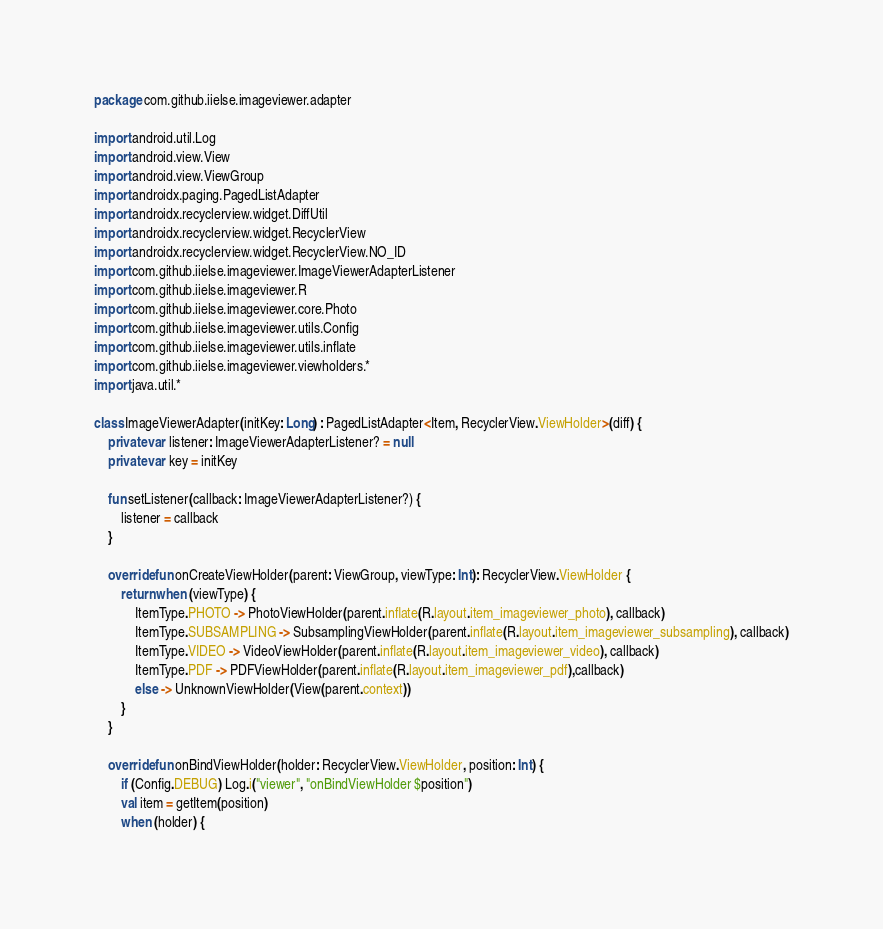<code> <loc_0><loc_0><loc_500><loc_500><_Kotlin_>package com.github.iielse.imageviewer.adapter

import android.util.Log
import android.view.View
import android.view.ViewGroup
import androidx.paging.PagedListAdapter
import androidx.recyclerview.widget.DiffUtil
import androidx.recyclerview.widget.RecyclerView
import androidx.recyclerview.widget.RecyclerView.NO_ID
import com.github.iielse.imageviewer.ImageViewerAdapterListener
import com.github.iielse.imageviewer.R
import com.github.iielse.imageviewer.core.Photo
import com.github.iielse.imageviewer.utils.Config
import com.github.iielse.imageviewer.utils.inflate
import com.github.iielse.imageviewer.viewholders.*
import java.util.*

class ImageViewerAdapter(initKey: Long) : PagedListAdapter<Item, RecyclerView.ViewHolder>(diff) {
    private var listener: ImageViewerAdapterListener? = null
    private var key = initKey

    fun setListener(callback: ImageViewerAdapterListener?) {
        listener = callback
    }

    override fun onCreateViewHolder(parent: ViewGroup, viewType: Int): RecyclerView.ViewHolder {
        return when (viewType) {
            ItemType.PHOTO -> PhotoViewHolder(parent.inflate(R.layout.item_imageviewer_photo), callback)
            ItemType.SUBSAMPLING -> SubsamplingViewHolder(parent.inflate(R.layout.item_imageviewer_subsampling), callback)
            ItemType.VIDEO -> VideoViewHolder(parent.inflate(R.layout.item_imageviewer_video), callback)
            ItemType.PDF -> PDFViewHolder(parent.inflate(R.layout.item_imageviewer_pdf),callback)
            else -> UnknownViewHolder(View(parent.context))
        }
    }

    override fun onBindViewHolder(holder: RecyclerView.ViewHolder, position: Int) {
        if (Config.DEBUG) Log.i("viewer", "onBindViewHolder $position")
        val item = getItem(position)
        when (holder) {</code> 